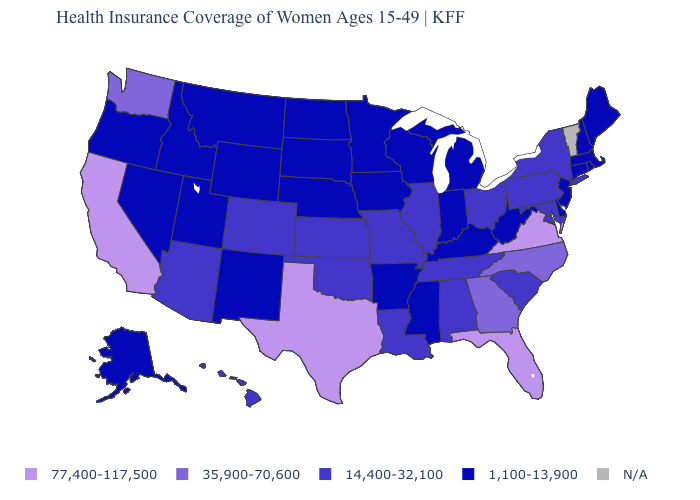What is the value of Louisiana?
Write a very short answer. 14,400-32,100. Does the map have missing data?
Concise answer only. Yes. What is the value of Washington?
Write a very short answer. 35,900-70,600. Is the legend a continuous bar?
Be succinct. No. Name the states that have a value in the range N/A?
Keep it brief. Vermont. Name the states that have a value in the range 77,400-117,500?
Quick response, please. California, Florida, Texas, Virginia. Name the states that have a value in the range 14,400-32,100?
Concise answer only. Alabama, Arizona, Colorado, Hawaii, Illinois, Kansas, Louisiana, Maryland, Missouri, New York, Ohio, Oklahoma, Pennsylvania, South Carolina, Tennessee. Name the states that have a value in the range N/A?
Give a very brief answer. Vermont. Does the first symbol in the legend represent the smallest category?
Short answer required. No. Does Texas have the highest value in the USA?
Concise answer only. Yes. Name the states that have a value in the range 1,100-13,900?
Keep it brief. Alaska, Arkansas, Connecticut, Delaware, Idaho, Indiana, Iowa, Kentucky, Maine, Massachusetts, Michigan, Minnesota, Mississippi, Montana, Nebraska, Nevada, New Hampshire, New Jersey, New Mexico, North Dakota, Oregon, Rhode Island, South Dakota, Utah, West Virginia, Wisconsin, Wyoming. Does the map have missing data?
Quick response, please. Yes. What is the value of Connecticut?
Concise answer only. 1,100-13,900. What is the value of Maryland?
Write a very short answer. 14,400-32,100. What is the lowest value in the MidWest?
Concise answer only. 1,100-13,900. 